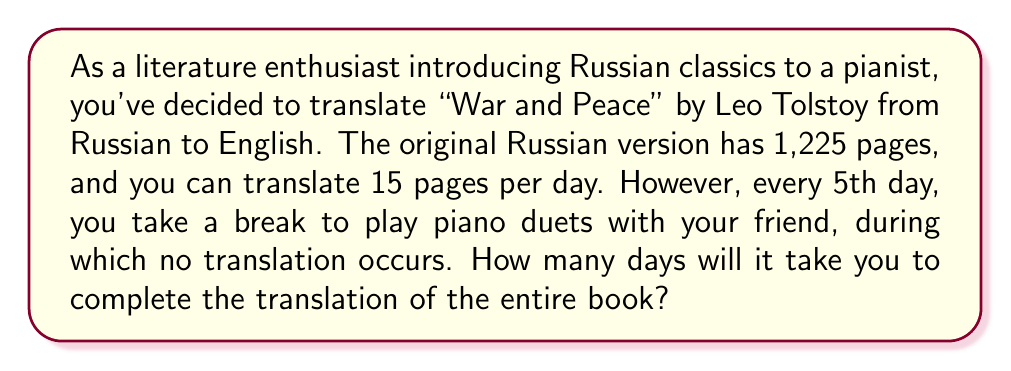Teach me how to tackle this problem. Let's approach this problem step by step:

1) First, let's calculate how many days of actual translation work are needed:
   $$\text{Total pages} \div \text{Pages per day} = 1225 \div 15 = 81\frac{2}{3} \text{ days}$$

2) Now, we need to account for the piano duet days. For every 4 days of translation, there's 1 day of piano playing.

3) Let's set up an equation:
   Let $x$ be the total number of days.
   $$4x + x = 5x = \text{total days}$$
   Where $4x$ represents the translation days and $x$ represents the piano days.

4) We know that the translation days should equal $81\frac{2}{3}$:
   $$4x = 81\frac{2}{3}$$

5) Solve for $x$:
   $$x = 81\frac{2}{3} \div 4 = 20\frac{5}{12}$$

6) But remember, $x$ only represents 4/5 of the total days. To get the total days, we multiply by $\frac{5}{4}$:
   $$20\frac{5}{12} \times \frac{5}{4} = 25\frac{25}{48} \text{ days}$$

7) Since we can't have a fractional day, we round up to the nearest whole number:
   $$25\frac{25}{48} \approx 26 \text{ days}$$
Answer: It will take 26 days to complete the translation of "War and Peace". 